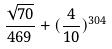Convert formula to latex. <formula><loc_0><loc_0><loc_500><loc_500>\frac { \sqrt { 7 0 } } { 4 6 9 } + ( \frac { 4 } { 1 0 } ) ^ { 3 0 4 }</formula> 